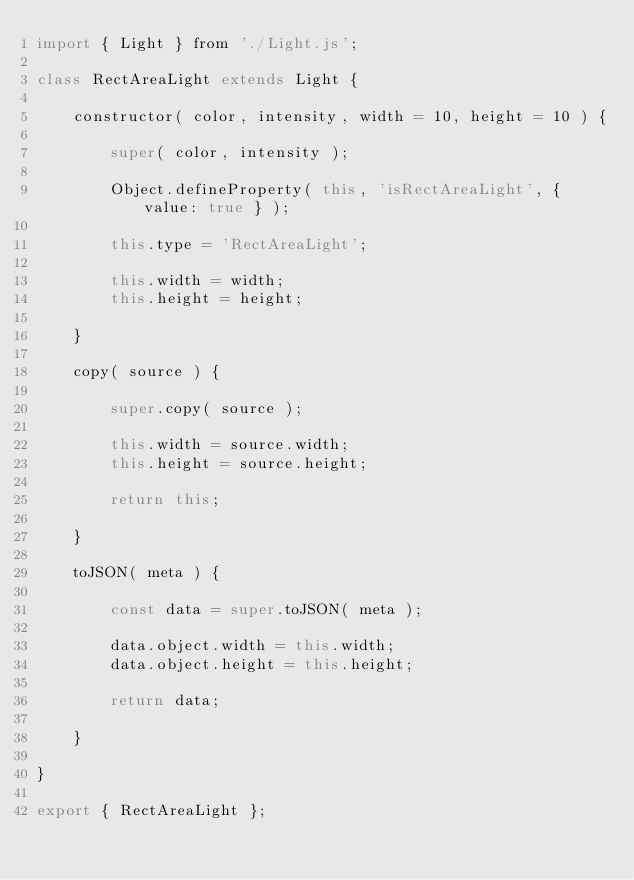Convert code to text. <code><loc_0><loc_0><loc_500><loc_500><_JavaScript_>import { Light } from './Light.js';

class RectAreaLight extends Light {

	constructor( color, intensity, width = 10, height = 10 ) {

		super( color, intensity );

		Object.defineProperty( this, 'isRectAreaLight', { value: true } );

		this.type = 'RectAreaLight';

		this.width = width;
		this.height = height;

	}

	copy( source ) {

		super.copy( source );

		this.width = source.width;
		this.height = source.height;

		return this;

	}

	toJSON( meta ) {

		const data = super.toJSON( meta );

		data.object.width = this.width;
		data.object.height = this.height;

		return data;

	}

}

export { RectAreaLight };
</code> 